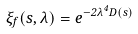<formula> <loc_0><loc_0><loc_500><loc_500>\xi _ { f } ( \vec { s } , \lambda ) = e ^ { - 2 \lambda ^ { 4 } D ( \vec { s } ) }</formula> 